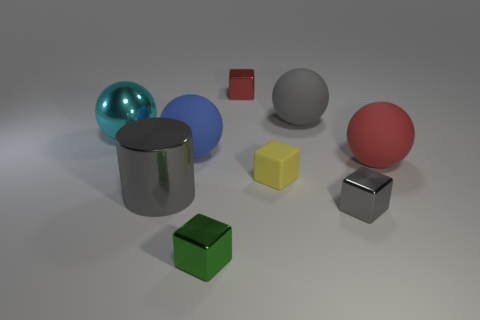Subtract 1 balls. How many balls are left? 3 Subtract all yellow balls. Subtract all purple blocks. How many balls are left? 4 Add 1 tiny blue rubber things. How many objects exist? 10 Subtract all cylinders. How many objects are left? 8 Subtract all green metal things. Subtract all gray spheres. How many objects are left? 7 Add 2 matte blocks. How many matte blocks are left? 3 Add 6 large gray shiny cylinders. How many large gray shiny cylinders exist? 7 Subtract 0 blue cylinders. How many objects are left? 9 